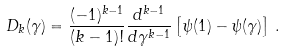<formula> <loc_0><loc_0><loc_500><loc_500>D _ { k } ( \gamma ) = \frac { ( - 1 ) ^ { k - 1 } } { ( k - 1 ) ! } \frac { d ^ { k - 1 } } { d \gamma ^ { k - 1 } } \left [ \psi ( 1 ) - \psi ( \gamma ) \right ] \, .</formula> 